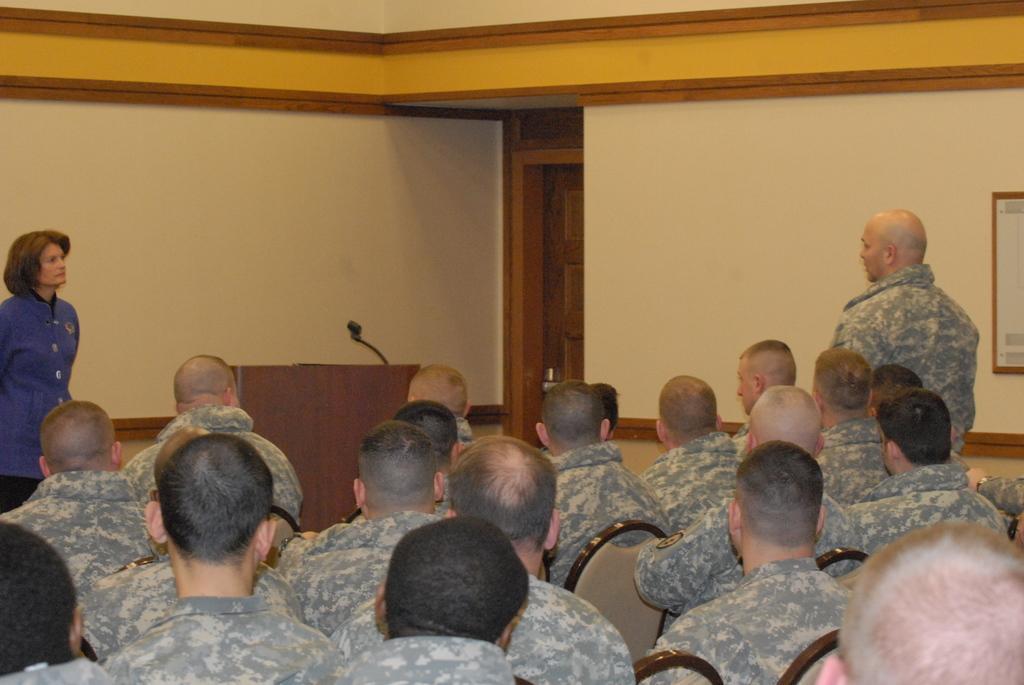Can you describe this image briefly? There are persons in uniform sitting on chairs. On the left side, there is a woman in blue color shirt standing. On the right, there is a person in an uniform, standing. In the background, there is a frame on the wall, there is a stand on which, there is a mic and there is a door. 